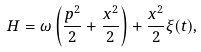Convert formula to latex. <formula><loc_0><loc_0><loc_500><loc_500>H = \omega \left ( \frac { p ^ { 2 } } { 2 } + \frac { x ^ { 2 } } { 2 } \right ) + \frac { x ^ { 2 } } { 2 } \xi ( t ) ,</formula> 